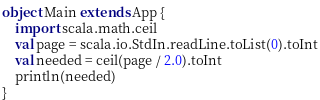<code> <loc_0><loc_0><loc_500><loc_500><_Scala_>object Main extends App {
    import scala.math.ceil
    val page = scala.io.StdIn.readLine.toList(0).toInt
    val needed = ceil(page / 2.0).toInt
    println(needed)
}</code> 